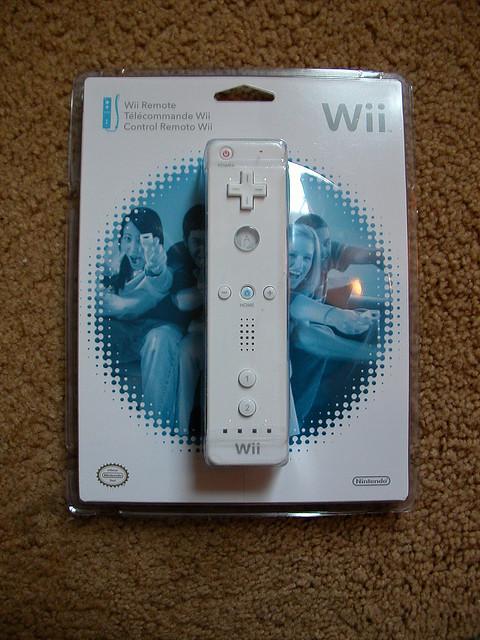How many buttons are on the remote?
Concise answer only. 6. Is the packaging open for the controller?
Write a very short answer. No. What kind of remote is pictured?
Be succinct. Wii. 